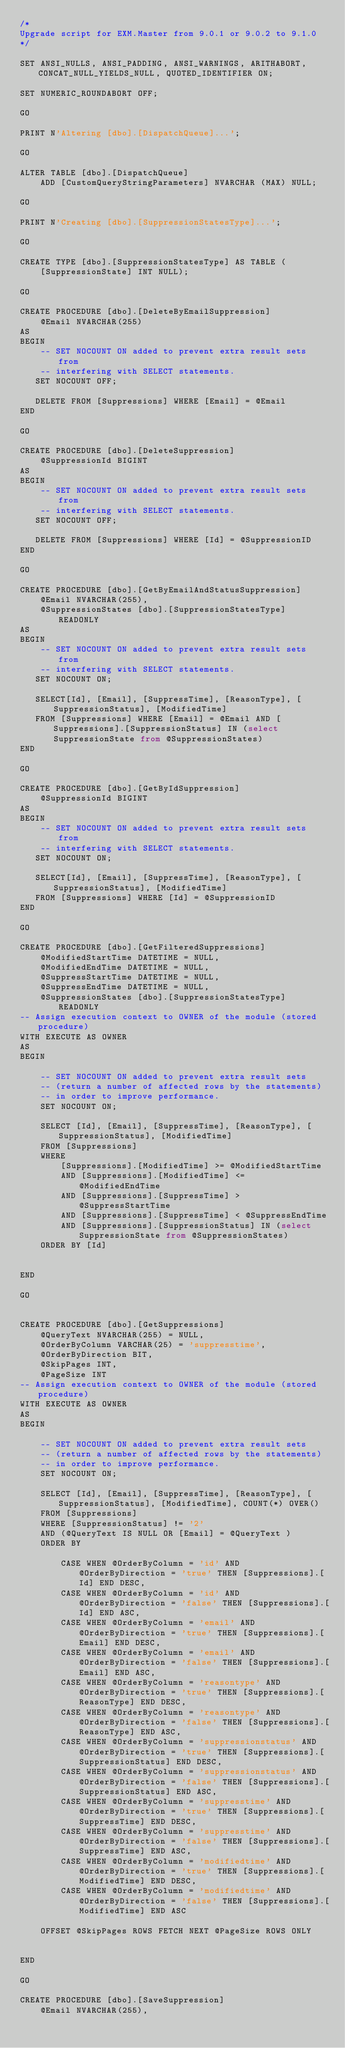<code> <loc_0><loc_0><loc_500><loc_500><_SQL_>/*
Upgrade script for EXM.Master from 9.0.1 or 9.0.2 to 9.1.0
*/

SET ANSI_NULLS, ANSI_PADDING, ANSI_WARNINGS, ARITHABORT, CONCAT_NULL_YIELDS_NULL, QUOTED_IDENTIFIER ON;

SET NUMERIC_ROUNDABORT OFF;

GO

PRINT N'Altering [dbo].[DispatchQueue]...';

GO

ALTER TABLE [dbo].[DispatchQueue]
    ADD [CustomQueryStringParameters] NVARCHAR (MAX) NULL;

GO

PRINT N'Creating [dbo].[SuppressionStatesType]...';

GO

CREATE TYPE [dbo].[SuppressionStatesType] AS TABLE (
    [SuppressionState] INT NULL);

GO

CREATE PROCEDURE [dbo].[DeleteByEmailSuppression]
	@Email NVARCHAR(255)
AS
BEGIN
	-- SET NOCOUNT ON added to prevent extra result sets from
	-- interfering with SELECT statements.
   SET NOCOUNT OFF;

   DELETE FROM [Suppressions] WHERE [Email] = @Email
END

GO

CREATE PROCEDURE [dbo].[DeleteSuppression]
	@SuppressionId BIGINT
AS
BEGIN
	-- SET NOCOUNT ON added to prevent extra result sets from
	-- interfering with SELECT statements.
   SET NOCOUNT OFF;

   DELETE FROM [Suppressions] WHERE [Id] = @SuppressionID
END

GO

CREATE PROCEDURE [dbo].[GetByEmailAndStatusSuppression]
	@Email NVARCHAR(255),
	@SuppressionStates [dbo].[SuppressionStatesType] READONLY
AS
BEGIN
	-- SET NOCOUNT ON added to prevent extra result sets from
	-- interfering with SELECT statements.
   SET NOCOUNT ON;

   SELECT[Id], [Email], [SuppressTime], [ReasonType], [SuppressionStatus], [ModifiedTime] 
   FROM [Suppressions] WHERE [Email] = @Email AND [Suppressions].[SuppressionStatus] IN (select SuppressionState from @SuppressionStates)
END

GO

CREATE PROCEDURE [dbo].[GetByIdSuppression]
	@SuppressionId BIGINT
AS
BEGIN
	-- SET NOCOUNT ON added to prevent extra result sets from
	-- interfering with SELECT statements.
   SET NOCOUNT ON;

   SELECT[Id], [Email], [SuppressTime], [ReasonType], [SuppressionStatus], [ModifiedTime] 
   FROM [Suppressions] WHERE [Id] = @SuppressionID
END

GO

CREATE PROCEDURE [dbo].[GetFilteredSuppressions] 
    @ModifiedStartTime DATETIME = NULL,
    @ModifiedEndTime DATETIME = NULL,
    @SuppressStartTime DATETIME = NULL,
    @SuppressEndTime DATETIME = NULL,
	@SuppressionStates [dbo].[SuppressionStatesType] READONLY
-- Assign execution context to OWNER of the module (stored procedure)
WITH EXECUTE AS OWNER 
AS
BEGIN

    -- SET NOCOUNT ON added to prevent extra result sets 
    -- (return a number of affected rows by the statements)
    -- in order to improve performance.
    SET NOCOUNT ON;

    SELECT [Id], [Email], [SuppressTime], [ReasonType], [SuppressionStatus], [ModifiedTime]
	FROM [Suppressions]
	WHERE 
		[Suppressions].[ModifiedTime] >= @ModifiedStartTime
		AND [Suppressions].[ModifiedTime] <= @ModifiedEndTime
		AND [Suppressions].[SuppressTime] > @SuppressStartTime
		AND [Suppressions].[SuppressTime] < @SuppressEndTime
		AND [Suppressions].[SuppressionStatus] IN (select SuppressionState from @SuppressionStates)
    ORDER BY [Id]

	
END

GO


CREATE PROCEDURE [dbo].[GetSuppressions] 
	@QueryText NVARCHAR(255) = NULL,
    @OrderByColumn VARCHAR(25) = 'suppresstime',
    @OrderByDirection BIT,
	@SkipPages INT,
	@PageSize INT
-- Assign execution context to OWNER of the module (stored procedure)
WITH EXECUTE AS OWNER 
AS
BEGIN

    -- SET NOCOUNT ON added to prevent extra result sets 
    -- (return a number of affected rows by the statements)
    -- in order to improve performance.
    SET NOCOUNT ON;

    SELECT [Id], [Email], [SuppressTime], [ReasonType], [SuppressionStatus], [ModifiedTime], COUNT(*) OVER()
	FROM [Suppressions]
	WHERE [SuppressionStatus] != '2'
	AND (@QueryText IS NULL OR [Email] = @QueryText )
    ORDER BY

		CASE WHEN @OrderByColumn = 'id' AND @OrderByDirection = 'true' THEN [Suppressions].[Id] END DESC,    
		CASE WHEN @OrderByColumn = 'id' AND @OrderByDirection = 'false' THEN [Suppressions].[Id] END ASC,    
		CASE WHEN @OrderByColumn = 'email' AND @OrderByDirection = 'true' THEN [Suppressions].[Email] END DESC,
		CASE WHEN @OrderByColumn = 'email' AND @OrderByDirection = 'false' THEN [Suppressions].[Email] END ASC,
		CASE WHEN @OrderByColumn = 'reasontype' AND @OrderByDirection = 'true' THEN [Suppressions].[ReasonType] END DESC,
		CASE WHEN @OrderByColumn = 'reasontype' AND @OrderByDirection = 'false' THEN [Suppressions].[ReasonType] END ASC,
		CASE WHEN @OrderByColumn = 'suppressionstatus' AND @OrderByDirection = 'true' THEN [Suppressions].[SuppressionStatus] END DESC,
		CASE WHEN @OrderByColumn = 'suppressionstatus' AND @OrderByDirection = 'false' THEN [Suppressions].[SuppressionStatus] END ASC,
		CASE WHEN @OrderByColumn = 'suppresstime' AND @OrderByDirection = 'true' THEN [Suppressions].[SuppressTime] END DESC,
		CASE WHEN @OrderByColumn = 'suppresstime' AND @OrderByDirection = 'false' THEN [Suppressions].[SuppressTime] END ASC,
		CASE WHEN @OrderByColumn = 'modifiedtime' AND @OrderByDirection = 'true' THEN [Suppressions].[ModifiedTime] END DESC,
		CASE WHEN @OrderByColumn = 'modifiedtime' AND @OrderByDirection = 'false' THEN [Suppressions].[ModifiedTime] END ASC

    OFFSET @SkipPages ROWS FETCH NEXT @PageSize ROWS ONLY 

	
END

GO

CREATE PROCEDURE [dbo].[SaveSuppression]
	@Email NVARCHAR(255),</code> 